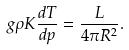Convert formula to latex. <formula><loc_0><loc_0><loc_500><loc_500>g \rho K \frac { d T } { d p } = \frac { L } { 4 \pi R ^ { 2 } } .</formula> 